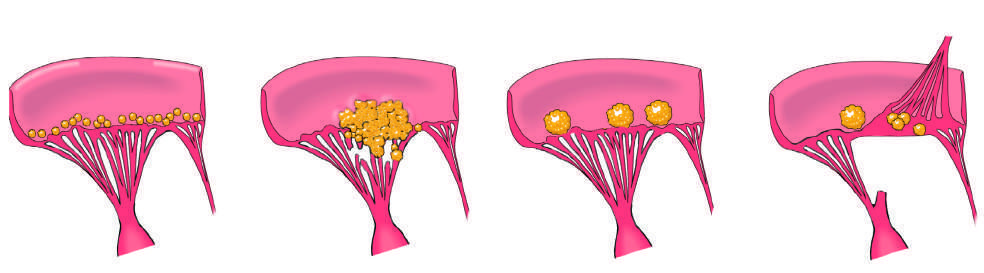s the acute rheumatic fever phase of rheumatic heart disease marked by the appearance of small, warty, inflammatory vegetations along the lines of valve closure?
Answer the question using a single word or phrase. Yes 